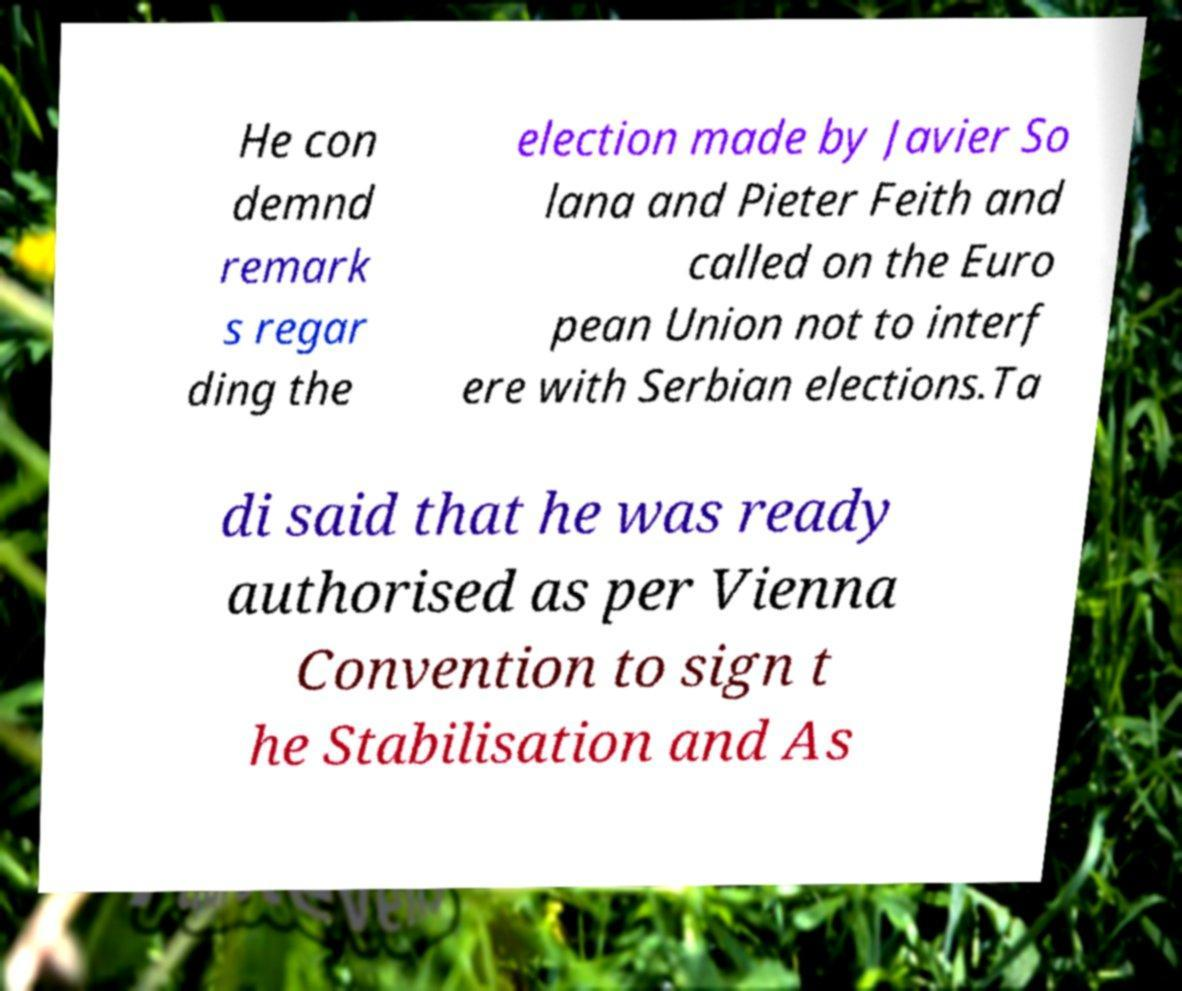Can you read and provide the text displayed in the image?This photo seems to have some interesting text. Can you extract and type it out for me? He con demnd remark s regar ding the election made by Javier So lana and Pieter Feith and called on the Euro pean Union not to interf ere with Serbian elections.Ta di said that he was ready authorised as per Vienna Convention to sign t he Stabilisation and As 